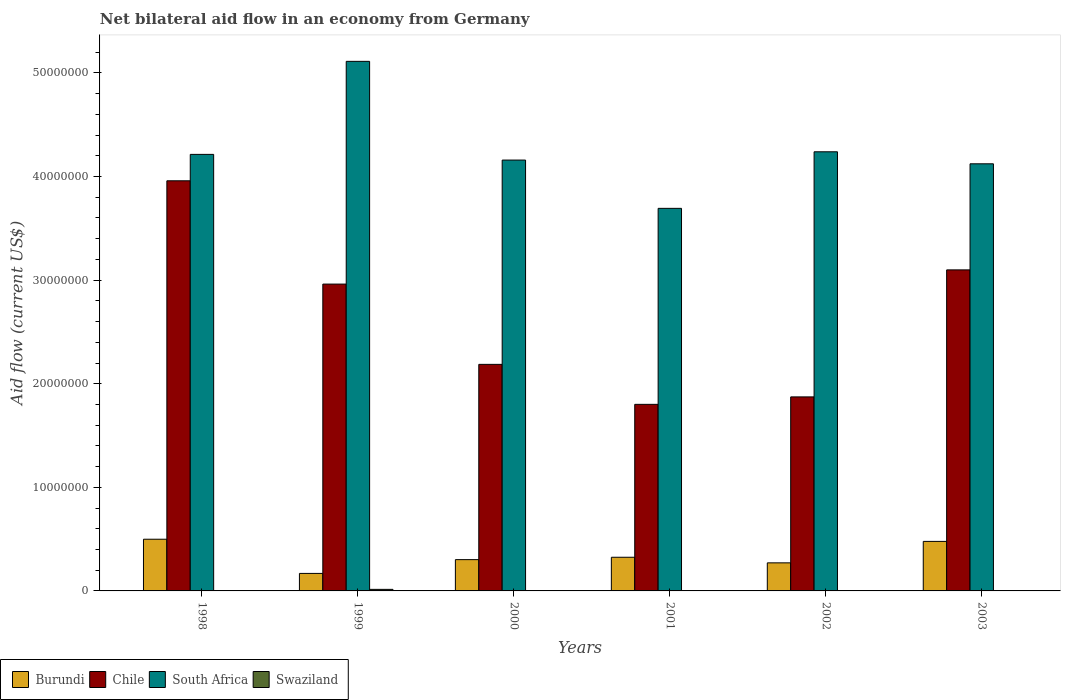How many different coloured bars are there?
Keep it short and to the point. 4. How many groups of bars are there?
Make the answer very short. 6. How many bars are there on the 2nd tick from the right?
Your response must be concise. 3. In how many cases, is the number of bars for a given year not equal to the number of legend labels?
Offer a terse response. 5. What is the net bilateral aid flow in Burundi in 2003?
Ensure brevity in your answer.  4.78e+06. Across all years, what is the maximum net bilateral aid flow in Swaziland?
Keep it short and to the point. 1.50e+05. Across all years, what is the minimum net bilateral aid flow in Burundi?
Provide a succinct answer. 1.69e+06. In which year was the net bilateral aid flow in Chile maximum?
Your answer should be compact. 1998. What is the difference between the net bilateral aid flow in Chile in 1998 and that in 2003?
Make the answer very short. 8.60e+06. What is the difference between the net bilateral aid flow in South Africa in 2000 and the net bilateral aid flow in Burundi in 2003?
Your answer should be very brief. 3.68e+07. What is the average net bilateral aid flow in Burundi per year?
Offer a terse response. 3.41e+06. In the year 1998, what is the difference between the net bilateral aid flow in Chile and net bilateral aid flow in Burundi?
Your answer should be very brief. 3.46e+07. In how many years, is the net bilateral aid flow in Burundi greater than 22000000 US$?
Your answer should be compact. 0. What is the ratio of the net bilateral aid flow in Chile in 2001 to that in 2002?
Your answer should be very brief. 0.96. What is the difference between the highest and the lowest net bilateral aid flow in Chile?
Give a very brief answer. 2.16e+07. In how many years, is the net bilateral aid flow in Chile greater than the average net bilateral aid flow in Chile taken over all years?
Make the answer very short. 3. What is the difference between two consecutive major ticks on the Y-axis?
Your answer should be very brief. 1.00e+07. Does the graph contain any zero values?
Ensure brevity in your answer.  Yes. How many legend labels are there?
Your answer should be very brief. 4. How are the legend labels stacked?
Provide a succinct answer. Horizontal. What is the title of the graph?
Ensure brevity in your answer.  Net bilateral aid flow in an economy from Germany. Does "Lesotho" appear as one of the legend labels in the graph?
Ensure brevity in your answer.  No. What is the label or title of the X-axis?
Keep it short and to the point. Years. What is the Aid flow (current US$) in Burundi in 1998?
Ensure brevity in your answer.  4.99e+06. What is the Aid flow (current US$) in Chile in 1998?
Give a very brief answer. 3.96e+07. What is the Aid flow (current US$) in South Africa in 1998?
Make the answer very short. 4.21e+07. What is the Aid flow (current US$) of Swaziland in 1998?
Give a very brief answer. 0. What is the Aid flow (current US$) of Burundi in 1999?
Provide a succinct answer. 1.69e+06. What is the Aid flow (current US$) in Chile in 1999?
Keep it short and to the point. 2.96e+07. What is the Aid flow (current US$) in South Africa in 1999?
Your response must be concise. 5.11e+07. What is the Aid flow (current US$) of Swaziland in 1999?
Offer a very short reply. 1.50e+05. What is the Aid flow (current US$) in Burundi in 2000?
Ensure brevity in your answer.  3.02e+06. What is the Aid flow (current US$) of Chile in 2000?
Ensure brevity in your answer.  2.19e+07. What is the Aid flow (current US$) of South Africa in 2000?
Your answer should be compact. 4.16e+07. What is the Aid flow (current US$) of Swaziland in 2000?
Keep it short and to the point. 0. What is the Aid flow (current US$) in Burundi in 2001?
Your answer should be compact. 3.25e+06. What is the Aid flow (current US$) of Chile in 2001?
Provide a succinct answer. 1.80e+07. What is the Aid flow (current US$) in South Africa in 2001?
Your answer should be compact. 3.69e+07. What is the Aid flow (current US$) of Swaziland in 2001?
Keep it short and to the point. 0. What is the Aid flow (current US$) of Burundi in 2002?
Your response must be concise. 2.71e+06. What is the Aid flow (current US$) in Chile in 2002?
Keep it short and to the point. 1.87e+07. What is the Aid flow (current US$) of South Africa in 2002?
Make the answer very short. 4.24e+07. What is the Aid flow (current US$) of Swaziland in 2002?
Give a very brief answer. 0. What is the Aid flow (current US$) in Burundi in 2003?
Your answer should be very brief. 4.78e+06. What is the Aid flow (current US$) of Chile in 2003?
Offer a terse response. 3.10e+07. What is the Aid flow (current US$) of South Africa in 2003?
Your answer should be compact. 4.12e+07. Across all years, what is the maximum Aid flow (current US$) of Burundi?
Offer a terse response. 4.99e+06. Across all years, what is the maximum Aid flow (current US$) of Chile?
Offer a very short reply. 3.96e+07. Across all years, what is the maximum Aid flow (current US$) in South Africa?
Offer a terse response. 5.11e+07. Across all years, what is the minimum Aid flow (current US$) in Burundi?
Make the answer very short. 1.69e+06. Across all years, what is the minimum Aid flow (current US$) in Chile?
Keep it short and to the point. 1.80e+07. Across all years, what is the minimum Aid flow (current US$) in South Africa?
Offer a terse response. 3.69e+07. Across all years, what is the minimum Aid flow (current US$) of Swaziland?
Your answer should be very brief. 0. What is the total Aid flow (current US$) in Burundi in the graph?
Your answer should be very brief. 2.04e+07. What is the total Aid flow (current US$) of Chile in the graph?
Make the answer very short. 1.59e+08. What is the total Aid flow (current US$) of South Africa in the graph?
Offer a terse response. 2.55e+08. What is the total Aid flow (current US$) in Swaziland in the graph?
Provide a succinct answer. 1.50e+05. What is the difference between the Aid flow (current US$) of Burundi in 1998 and that in 1999?
Offer a very short reply. 3.30e+06. What is the difference between the Aid flow (current US$) of Chile in 1998 and that in 1999?
Offer a very short reply. 9.97e+06. What is the difference between the Aid flow (current US$) of South Africa in 1998 and that in 1999?
Give a very brief answer. -8.98e+06. What is the difference between the Aid flow (current US$) in Burundi in 1998 and that in 2000?
Your response must be concise. 1.97e+06. What is the difference between the Aid flow (current US$) in Chile in 1998 and that in 2000?
Your answer should be compact. 1.77e+07. What is the difference between the Aid flow (current US$) in Burundi in 1998 and that in 2001?
Ensure brevity in your answer.  1.74e+06. What is the difference between the Aid flow (current US$) of Chile in 1998 and that in 2001?
Provide a succinct answer. 2.16e+07. What is the difference between the Aid flow (current US$) of South Africa in 1998 and that in 2001?
Your answer should be compact. 5.21e+06. What is the difference between the Aid flow (current US$) in Burundi in 1998 and that in 2002?
Your response must be concise. 2.28e+06. What is the difference between the Aid flow (current US$) of Chile in 1998 and that in 2002?
Ensure brevity in your answer.  2.09e+07. What is the difference between the Aid flow (current US$) of South Africa in 1998 and that in 2002?
Your answer should be very brief. -2.50e+05. What is the difference between the Aid flow (current US$) in Burundi in 1998 and that in 2003?
Ensure brevity in your answer.  2.10e+05. What is the difference between the Aid flow (current US$) in Chile in 1998 and that in 2003?
Ensure brevity in your answer.  8.60e+06. What is the difference between the Aid flow (current US$) of South Africa in 1998 and that in 2003?
Make the answer very short. 9.10e+05. What is the difference between the Aid flow (current US$) of Burundi in 1999 and that in 2000?
Your answer should be very brief. -1.33e+06. What is the difference between the Aid flow (current US$) in Chile in 1999 and that in 2000?
Your response must be concise. 7.75e+06. What is the difference between the Aid flow (current US$) of South Africa in 1999 and that in 2000?
Ensure brevity in your answer.  9.53e+06. What is the difference between the Aid flow (current US$) of Burundi in 1999 and that in 2001?
Your answer should be compact. -1.56e+06. What is the difference between the Aid flow (current US$) in Chile in 1999 and that in 2001?
Your response must be concise. 1.16e+07. What is the difference between the Aid flow (current US$) in South Africa in 1999 and that in 2001?
Your answer should be very brief. 1.42e+07. What is the difference between the Aid flow (current US$) in Burundi in 1999 and that in 2002?
Provide a short and direct response. -1.02e+06. What is the difference between the Aid flow (current US$) of Chile in 1999 and that in 2002?
Ensure brevity in your answer.  1.09e+07. What is the difference between the Aid flow (current US$) of South Africa in 1999 and that in 2002?
Offer a very short reply. 8.73e+06. What is the difference between the Aid flow (current US$) of Burundi in 1999 and that in 2003?
Your answer should be very brief. -3.09e+06. What is the difference between the Aid flow (current US$) in Chile in 1999 and that in 2003?
Offer a very short reply. -1.37e+06. What is the difference between the Aid flow (current US$) in South Africa in 1999 and that in 2003?
Your answer should be very brief. 9.89e+06. What is the difference between the Aid flow (current US$) in Burundi in 2000 and that in 2001?
Give a very brief answer. -2.30e+05. What is the difference between the Aid flow (current US$) in Chile in 2000 and that in 2001?
Make the answer very short. 3.86e+06. What is the difference between the Aid flow (current US$) of South Africa in 2000 and that in 2001?
Give a very brief answer. 4.66e+06. What is the difference between the Aid flow (current US$) in Burundi in 2000 and that in 2002?
Make the answer very short. 3.10e+05. What is the difference between the Aid flow (current US$) of Chile in 2000 and that in 2002?
Ensure brevity in your answer.  3.14e+06. What is the difference between the Aid flow (current US$) in South Africa in 2000 and that in 2002?
Provide a short and direct response. -8.00e+05. What is the difference between the Aid flow (current US$) in Burundi in 2000 and that in 2003?
Provide a short and direct response. -1.76e+06. What is the difference between the Aid flow (current US$) in Chile in 2000 and that in 2003?
Give a very brief answer. -9.12e+06. What is the difference between the Aid flow (current US$) in Burundi in 2001 and that in 2002?
Your response must be concise. 5.40e+05. What is the difference between the Aid flow (current US$) of Chile in 2001 and that in 2002?
Ensure brevity in your answer.  -7.20e+05. What is the difference between the Aid flow (current US$) of South Africa in 2001 and that in 2002?
Your response must be concise. -5.46e+06. What is the difference between the Aid flow (current US$) in Burundi in 2001 and that in 2003?
Your response must be concise. -1.53e+06. What is the difference between the Aid flow (current US$) in Chile in 2001 and that in 2003?
Ensure brevity in your answer.  -1.30e+07. What is the difference between the Aid flow (current US$) of South Africa in 2001 and that in 2003?
Keep it short and to the point. -4.30e+06. What is the difference between the Aid flow (current US$) of Burundi in 2002 and that in 2003?
Give a very brief answer. -2.07e+06. What is the difference between the Aid flow (current US$) in Chile in 2002 and that in 2003?
Offer a terse response. -1.23e+07. What is the difference between the Aid flow (current US$) of South Africa in 2002 and that in 2003?
Ensure brevity in your answer.  1.16e+06. What is the difference between the Aid flow (current US$) of Burundi in 1998 and the Aid flow (current US$) of Chile in 1999?
Provide a succinct answer. -2.46e+07. What is the difference between the Aid flow (current US$) of Burundi in 1998 and the Aid flow (current US$) of South Africa in 1999?
Provide a succinct answer. -4.61e+07. What is the difference between the Aid flow (current US$) in Burundi in 1998 and the Aid flow (current US$) in Swaziland in 1999?
Give a very brief answer. 4.84e+06. What is the difference between the Aid flow (current US$) in Chile in 1998 and the Aid flow (current US$) in South Africa in 1999?
Give a very brief answer. -1.15e+07. What is the difference between the Aid flow (current US$) of Chile in 1998 and the Aid flow (current US$) of Swaziland in 1999?
Your answer should be compact. 3.94e+07. What is the difference between the Aid flow (current US$) in South Africa in 1998 and the Aid flow (current US$) in Swaziland in 1999?
Your answer should be compact. 4.20e+07. What is the difference between the Aid flow (current US$) of Burundi in 1998 and the Aid flow (current US$) of Chile in 2000?
Ensure brevity in your answer.  -1.69e+07. What is the difference between the Aid flow (current US$) in Burundi in 1998 and the Aid flow (current US$) in South Africa in 2000?
Your answer should be compact. -3.66e+07. What is the difference between the Aid flow (current US$) in Burundi in 1998 and the Aid flow (current US$) in Chile in 2001?
Provide a short and direct response. -1.30e+07. What is the difference between the Aid flow (current US$) of Burundi in 1998 and the Aid flow (current US$) of South Africa in 2001?
Provide a succinct answer. -3.19e+07. What is the difference between the Aid flow (current US$) of Chile in 1998 and the Aid flow (current US$) of South Africa in 2001?
Provide a succinct answer. 2.66e+06. What is the difference between the Aid flow (current US$) in Burundi in 1998 and the Aid flow (current US$) in Chile in 2002?
Keep it short and to the point. -1.37e+07. What is the difference between the Aid flow (current US$) in Burundi in 1998 and the Aid flow (current US$) in South Africa in 2002?
Give a very brief answer. -3.74e+07. What is the difference between the Aid flow (current US$) in Chile in 1998 and the Aid flow (current US$) in South Africa in 2002?
Keep it short and to the point. -2.80e+06. What is the difference between the Aid flow (current US$) of Burundi in 1998 and the Aid flow (current US$) of Chile in 2003?
Ensure brevity in your answer.  -2.60e+07. What is the difference between the Aid flow (current US$) of Burundi in 1998 and the Aid flow (current US$) of South Africa in 2003?
Provide a short and direct response. -3.62e+07. What is the difference between the Aid flow (current US$) in Chile in 1998 and the Aid flow (current US$) in South Africa in 2003?
Offer a very short reply. -1.64e+06. What is the difference between the Aid flow (current US$) in Burundi in 1999 and the Aid flow (current US$) in Chile in 2000?
Keep it short and to the point. -2.02e+07. What is the difference between the Aid flow (current US$) in Burundi in 1999 and the Aid flow (current US$) in South Africa in 2000?
Ensure brevity in your answer.  -3.99e+07. What is the difference between the Aid flow (current US$) in Chile in 1999 and the Aid flow (current US$) in South Africa in 2000?
Your answer should be very brief. -1.20e+07. What is the difference between the Aid flow (current US$) in Burundi in 1999 and the Aid flow (current US$) in Chile in 2001?
Offer a very short reply. -1.63e+07. What is the difference between the Aid flow (current US$) of Burundi in 1999 and the Aid flow (current US$) of South Africa in 2001?
Provide a succinct answer. -3.52e+07. What is the difference between the Aid flow (current US$) of Chile in 1999 and the Aid flow (current US$) of South Africa in 2001?
Provide a succinct answer. -7.31e+06. What is the difference between the Aid flow (current US$) of Burundi in 1999 and the Aid flow (current US$) of Chile in 2002?
Your answer should be compact. -1.70e+07. What is the difference between the Aid flow (current US$) of Burundi in 1999 and the Aid flow (current US$) of South Africa in 2002?
Your answer should be compact. -4.07e+07. What is the difference between the Aid flow (current US$) in Chile in 1999 and the Aid flow (current US$) in South Africa in 2002?
Your answer should be compact. -1.28e+07. What is the difference between the Aid flow (current US$) in Burundi in 1999 and the Aid flow (current US$) in Chile in 2003?
Offer a terse response. -2.93e+07. What is the difference between the Aid flow (current US$) in Burundi in 1999 and the Aid flow (current US$) in South Africa in 2003?
Offer a very short reply. -3.95e+07. What is the difference between the Aid flow (current US$) in Chile in 1999 and the Aid flow (current US$) in South Africa in 2003?
Offer a very short reply. -1.16e+07. What is the difference between the Aid flow (current US$) of Burundi in 2000 and the Aid flow (current US$) of Chile in 2001?
Provide a short and direct response. -1.50e+07. What is the difference between the Aid flow (current US$) of Burundi in 2000 and the Aid flow (current US$) of South Africa in 2001?
Provide a short and direct response. -3.39e+07. What is the difference between the Aid flow (current US$) of Chile in 2000 and the Aid flow (current US$) of South Africa in 2001?
Offer a terse response. -1.51e+07. What is the difference between the Aid flow (current US$) in Burundi in 2000 and the Aid flow (current US$) in Chile in 2002?
Offer a very short reply. -1.57e+07. What is the difference between the Aid flow (current US$) of Burundi in 2000 and the Aid flow (current US$) of South Africa in 2002?
Keep it short and to the point. -3.94e+07. What is the difference between the Aid flow (current US$) of Chile in 2000 and the Aid flow (current US$) of South Africa in 2002?
Provide a succinct answer. -2.05e+07. What is the difference between the Aid flow (current US$) in Burundi in 2000 and the Aid flow (current US$) in Chile in 2003?
Ensure brevity in your answer.  -2.80e+07. What is the difference between the Aid flow (current US$) of Burundi in 2000 and the Aid flow (current US$) of South Africa in 2003?
Your response must be concise. -3.82e+07. What is the difference between the Aid flow (current US$) in Chile in 2000 and the Aid flow (current US$) in South Africa in 2003?
Ensure brevity in your answer.  -1.94e+07. What is the difference between the Aid flow (current US$) of Burundi in 2001 and the Aid flow (current US$) of Chile in 2002?
Provide a succinct answer. -1.55e+07. What is the difference between the Aid flow (current US$) of Burundi in 2001 and the Aid flow (current US$) of South Africa in 2002?
Provide a short and direct response. -3.91e+07. What is the difference between the Aid flow (current US$) in Chile in 2001 and the Aid flow (current US$) in South Africa in 2002?
Keep it short and to the point. -2.44e+07. What is the difference between the Aid flow (current US$) of Burundi in 2001 and the Aid flow (current US$) of Chile in 2003?
Your response must be concise. -2.77e+07. What is the difference between the Aid flow (current US$) of Burundi in 2001 and the Aid flow (current US$) of South Africa in 2003?
Provide a short and direct response. -3.80e+07. What is the difference between the Aid flow (current US$) in Chile in 2001 and the Aid flow (current US$) in South Africa in 2003?
Keep it short and to the point. -2.32e+07. What is the difference between the Aid flow (current US$) of Burundi in 2002 and the Aid flow (current US$) of Chile in 2003?
Keep it short and to the point. -2.83e+07. What is the difference between the Aid flow (current US$) of Burundi in 2002 and the Aid flow (current US$) of South Africa in 2003?
Give a very brief answer. -3.85e+07. What is the difference between the Aid flow (current US$) in Chile in 2002 and the Aid flow (current US$) in South Africa in 2003?
Make the answer very short. -2.25e+07. What is the average Aid flow (current US$) of Burundi per year?
Give a very brief answer. 3.41e+06. What is the average Aid flow (current US$) of Chile per year?
Your answer should be compact. 2.65e+07. What is the average Aid flow (current US$) of South Africa per year?
Your answer should be compact. 4.26e+07. What is the average Aid flow (current US$) in Swaziland per year?
Provide a short and direct response. 2.50e+04. In the year 1998, what is the difference between the Aid flow (current US$) in Burundi and Aid flow (current US$) in Chile?
Your response must be concise. -3.46e+07. In the year 1998, what is the difference between the Aid flow (current US$) of Burundi and Aid flow (current US$) of South Africa?
Offer a very short reply. -3.72e+07. In the year 1998, what is the difference between the Aid flow (current US$) of Chile and Aid flow (current US$) of South Africa?
Offer a very short reply. -2.55e+06. In the year 1999, what is the difference between the Aid flow (current US$) in Burundi and Aid flow (current US$) in Chile?
Provide a succinct answer. -2.79e+07. In the year 1999, what is the difference between the Aid flow (current US$) of Burundi and Aid flow (current US$) of South Africa?
Your answer should be compact. -4.94e+07. In the year 1999, what is the difference between the Aid flow (current US$) of Burundi and Aid flow (current US$) of Swaziland?
Give a very brief answer. 1.54e+06. In the year 1999, what is the difference between the Aid flow (current US$) in Chile and Aid flow (current US$) in South Africa?
Keep it short and to the point. -2.15e+07. In the year 1999, what is the difference between the Aid flow (current US$) of Chile and Aid flow (current US$) of Swaziland?
Make the answer very short. 2.95e+07. In the year 1999, what is the difference between the Aid flow (current US$) in South Africa and Aid flow (current US$) in Swaziland?
Provide a succinct answer. 5.10e+07. In the year 2000, what is the difference between the Aid flow (current US$) in Burundi and Aid flow (current US$) in Chile?
Ensure brevity in your answer.  -1.88e+07. In the year 2000, what is the difference between the Aid flow (current US$) of Burundi and Aid flow (current US$) of South Africa?
Keep it short and to the point. -3.86e+07. In the year 2000, what is the difference between the Aid flow (current US$) of Chile and Aid flow (current US$) of South Africa?
Your answer should be compact. -1.97e+07. In the year 2001, what is the difference between the Aid flow (current US$) of Burundi and Aid flow (current US$) of Chile?
Keep it short and to the point. -1.48e+07. In the year 2001, what is the difference between the Aid flow (current US$) of Burundi and Aid flow (current US$) of South Africa?
Provide a short and direct response. -3.37e+07. In the year 2001, what is the difference between the Aid flow (current US$) of Chile and Aid flow (current US$) of South Africa?
Offer a terse response. -1.89e+07. In the year 2002, what is the difference between the Aid flow (current US$) in Burundi and Aid flow (current US$) in Chile?
Your answer should be very brief. -1.60e+07. In the year 2002, what is the difference between the Aid flow (current US$) of Burundi and Aid flow (current US$) of South Africa?
Your answer should be very brief. -3.97e+07. In the year 2002, what is the difference between the Aid flow (current US$) in Chile and Aid flow (current US$) in South Africa?
Provide a succinct answer. -2.37e+07. In the year 2003, what is the difference between the Aid flow (current US$) of Burundi and Aid flow (current US$) of Chile?
Your answer should be very brief. -2.62e+07. In the year 2003, what is the difference between the Aid flow (current US$) of Burundi and Aid flow (current US$) of South Africa?
Provide a short and direct response. -3.64e+07. In the year 2003, what is the difference between the Aid flow (current US$) in Chile and Aid flow (current US$) in South Africa?
Provide a succinct answer. -1.02e+07. What is the ratio of the Aid flow (current US$) in Burundi in 1998 to that in 1999?
Provide a succinct answer. 2.95. What is the ratio of the Aid flow (current US$) of Chile in 1998 to that in 1999?
Your answer should be very brief. 1.34. What is the ratio of the Aid flow (current US$) in South Africa in 1998 to that in 1999?
Ensure brevity in your answer.  0.82. What is the ratio of the Aid flow (current US$) of Burundi in 1998 to that in 2000?
Provide a short and direct response. 1.65. What is the ratio of the Aid flow (current US$) in Chile in 1998 to that in 2000?
Ensure brevity in your answer.  1.81. What is the ratio of the Aid flow (current US$) in South Africa in 1998 to that in 2000?
Offer a very short reply. 1.01. What is the ratio of the Aid flow (current US$) of Burundi in 1998 to that in 2001?
Make the answer very short. 1.54. What is the ratio of the Aid flow (current US$) of Chile in 1998 to that in 2001?
Give a very brief answer. 2.2. What is the ratio of the Aid flow (current US$) in South Africa in 1998 to that in 2001?
Provide a short and direct response. 1.14. What is the ratio of the Aid flow (current US$) in Burundi in 1998 to that in 2002?
Ensure brevity in your answer.  1.84. What is the ratio of the Aid flow (current US$) of Chile in 1998 to that in 2002?
Provide a succinct answer. 2.11. What is the ratio of the Aid flow (current US$) of Burundi in 1998 to that in 2003?
Keep it short and to the point. 1.04. What is the ratio of the Aid flow (current US$) of Chile in 1998 to that in 2003?
Make the answer very short. 1.28. What is the ratio of the Aid flow (current US$) of South Africa in 1998 to that in 2003?
Give a very brief answer. 1.02. What is the ratio of the Aid flow (current US$) of Burundi in 1999 to that in 2000?
Offer a very short reply. 0.56. What is the ratio of the Aid flow (current US$) in Chile in 1999 to that in 2000?
Your answer should be compact. 1.35. What is the ratio of the Aid flow (current US$) in South Africa in 1999 to that in 2000?
Make the answer very short. 1.23. What is the ratio of the Aid flow (current US$) of Burundi in 1999 to that in 2001?
Offer a terse response. 0.52. What is the ratio of the Aid flow (current US$) of Chile in 1999 to that in 2001?
Provide a short and direct response. 1.64. What is the ratio of the Aid flow (current US$) of South Africa in 1999 to that in 2001?
Your answer should be very brief. 1.38. What is the ratio of the Aid flow (current US$) in Burundi in 1999 to that in 2002?
Ensure brevity in your answer.  0.62. What is the ratio of the Aid flow (current US$) in Chile in 1999 to that in 2002?
Your response must be concise. 1.58. What is the ratio of the Aid flow (current US$) in South Africa in 1999 to that in 2002?
Make the answer very short. 1.21. What is the ratio of the Aid flow (current US$) in Burundi in 1999 to that in 2003?
Offer a very short reply. 0.35. What is the ratio of the Aid flow (current US$) in Chile in 1999 to that in 2003?
Keep it short and to the point. 0.96. What is the ratio of the Aid flow (current US$) in South Africa in 1999 to that in 2003?
Ensure brevity in your answer.  1.24. What is the ratio of the Aid flow (current US$) of Burundi in 2000 to that in 2001?
Your answer should be compact. 0.93. What is the ratio of the Aid flow (current US$) in Chile in 2000 to that in 2001?
Provide a short and direct response. 1.21. What is the ratio of the Aid flow (current US$) of South Africa in 2000 to that in 2001?
Ensure brevity in your answer.  1.13. What is the ratio of the Aid flow (current US$) of Burundi in 2000 to that in 2002?
Provide a short and direct response. 1.11. What is the ratio of the Aid flow (current US$) in Chile in 2000 to that in 2002?
Provide a succinct answer. 1.17. What is the ratio of the Aid flow (current US$) in South Africa in 2000 to that in 2002?
Provide a succinct answer. 0.98. What is the ratio of the Aid flow (current US$) of Burundi in 2000 to that in 2003?
Give a very brief answer. 0.63. What is the ratio of the Aid flow (current US$) of Chile in 2000 to that in 2003?
Ensure brevity in your answer.  0.71. What is the ratio of the Aid flow (current US$) in South Africa in 2000 to that in 2003?
Provide a short and direct response. 1.01. What is the ratio of the Aid flow (current US$) in Burundi in 2001 to that in 2002?
Keep it short and to the point. 1.2. What is the ratio of the Aid flow (current US$) in Chile in 2001 to that in 2002?
Offer a very short reply. 0.96. What is the ratio of the Aid flow (current US$) in South Africa in 2001 to that in 2002?
Ensure brevity in your answer.  0.87. What is the ratio of the Aid flow (current US$) of Burundi in 2001 to that in 2003?
Offer a terse response. 0.68. What is the ratio of the Aid flow (current US$) in Chile in 2001 to that in 2003?
Keep it short and to the point. 0.58. What is the ratio of the Aid flow (current US$) in South Africa in 2001 to that in 2003?
Provide a short and direct response. 0.9. What is the ratio of the Aid flow (current US$) in Burundi in 2002 to that in 2003?
Provide a short and direct response. 0.57. What is the ratio of the Aid flow (current US$) in Chile in 2002 to that in 2003?
Make the answer very short. 0.6. What is the ratio of the Aid flow (current US$) of South Africa in 2002 to that in 2003?
Give a very brief answer. 1.03. What is the difference between the highest and the second highest Aid flow (current US$) of Burundi?
Offer a terse response. 2.10e+05. What is the difference between the highest and the second highest Aid flow (current US$) of Chile?
Provide a succinct answer. 8.60e+06. What is the difference between the highest and the second highest Aid flow (current US$) of South Africa?
Your answer should be compact. 8.73e+06. What is the difference between the highest and the lowest Aid flow (current US$) of Burundi?
Your response must be concise. 3.30e+06. What is the difference between the highest and the lowest Aid flow (current US$) in Chile?
Offer a terse response. 2.16e+07. What is the difference between the highest and the lowest Aid flow (current US$) of South Africa?
Provide a short and direct response. 1.42e+07. 